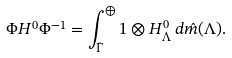Convert formula to latex. <formula><loc_0><loc_0><loc_500><loc_500>\Phi H ^ { 0 } \Phi ^ { - 1 } = \int _ { \hat { \Gamma } } ^ { \oplus } 1 \otimes H _ { \Lambda } ^ { 0 } \, d \hat { m } ( \Lambda ) .</formula> 